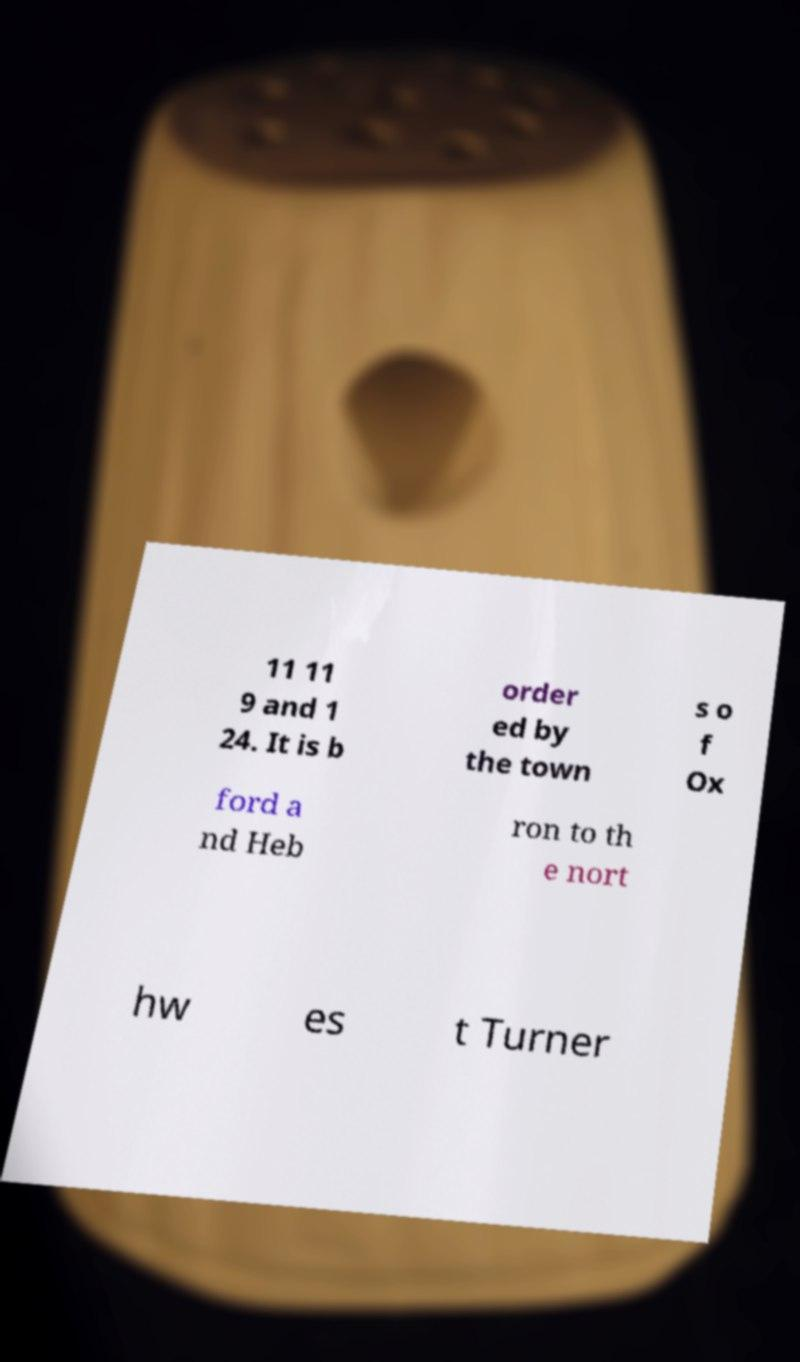For documentation purposes, I need the text within this image transcribed. Could you provide that? 11 11 9 and 1 24. It is b order ed by the town s o f Ox ford a nd Heb ron to th e nort hw es t Turner 